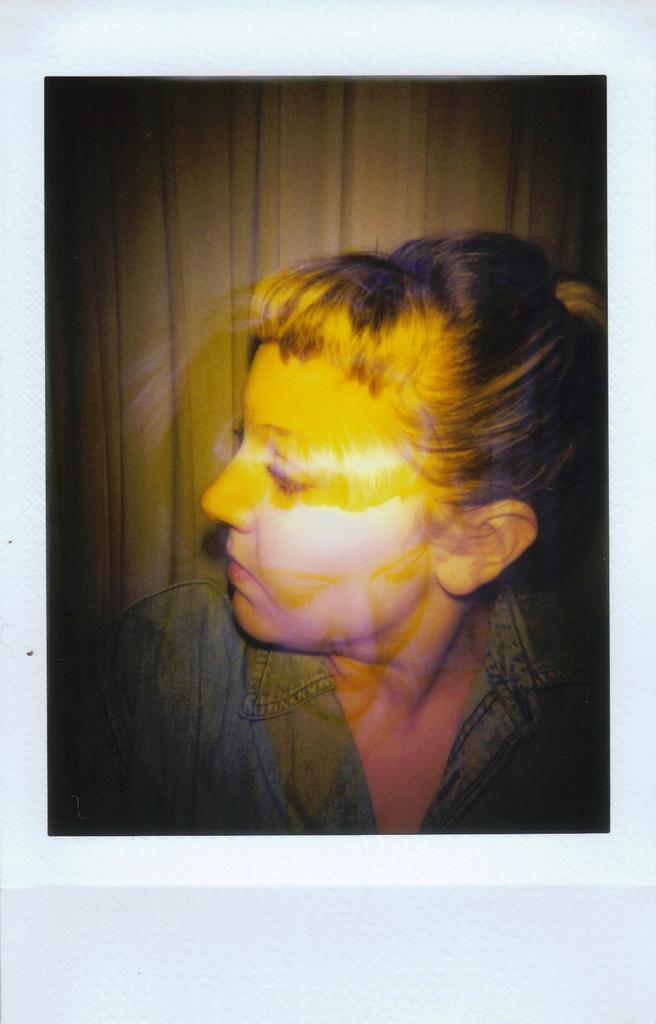What is the main subject of the image? There is a photograph of a woman in the image. What is the woman wearing in the photograph? The woman is wearing a blue dress. What is the color of the surface on which the photograph is placed? The photograph is on a white surface. What can be seen in the background of the image? There is a cream-colored curtain in the background. What type of comb is the woman using to brush her silk turkey in the image? There is no comb, silk, or turkey present in the image. 